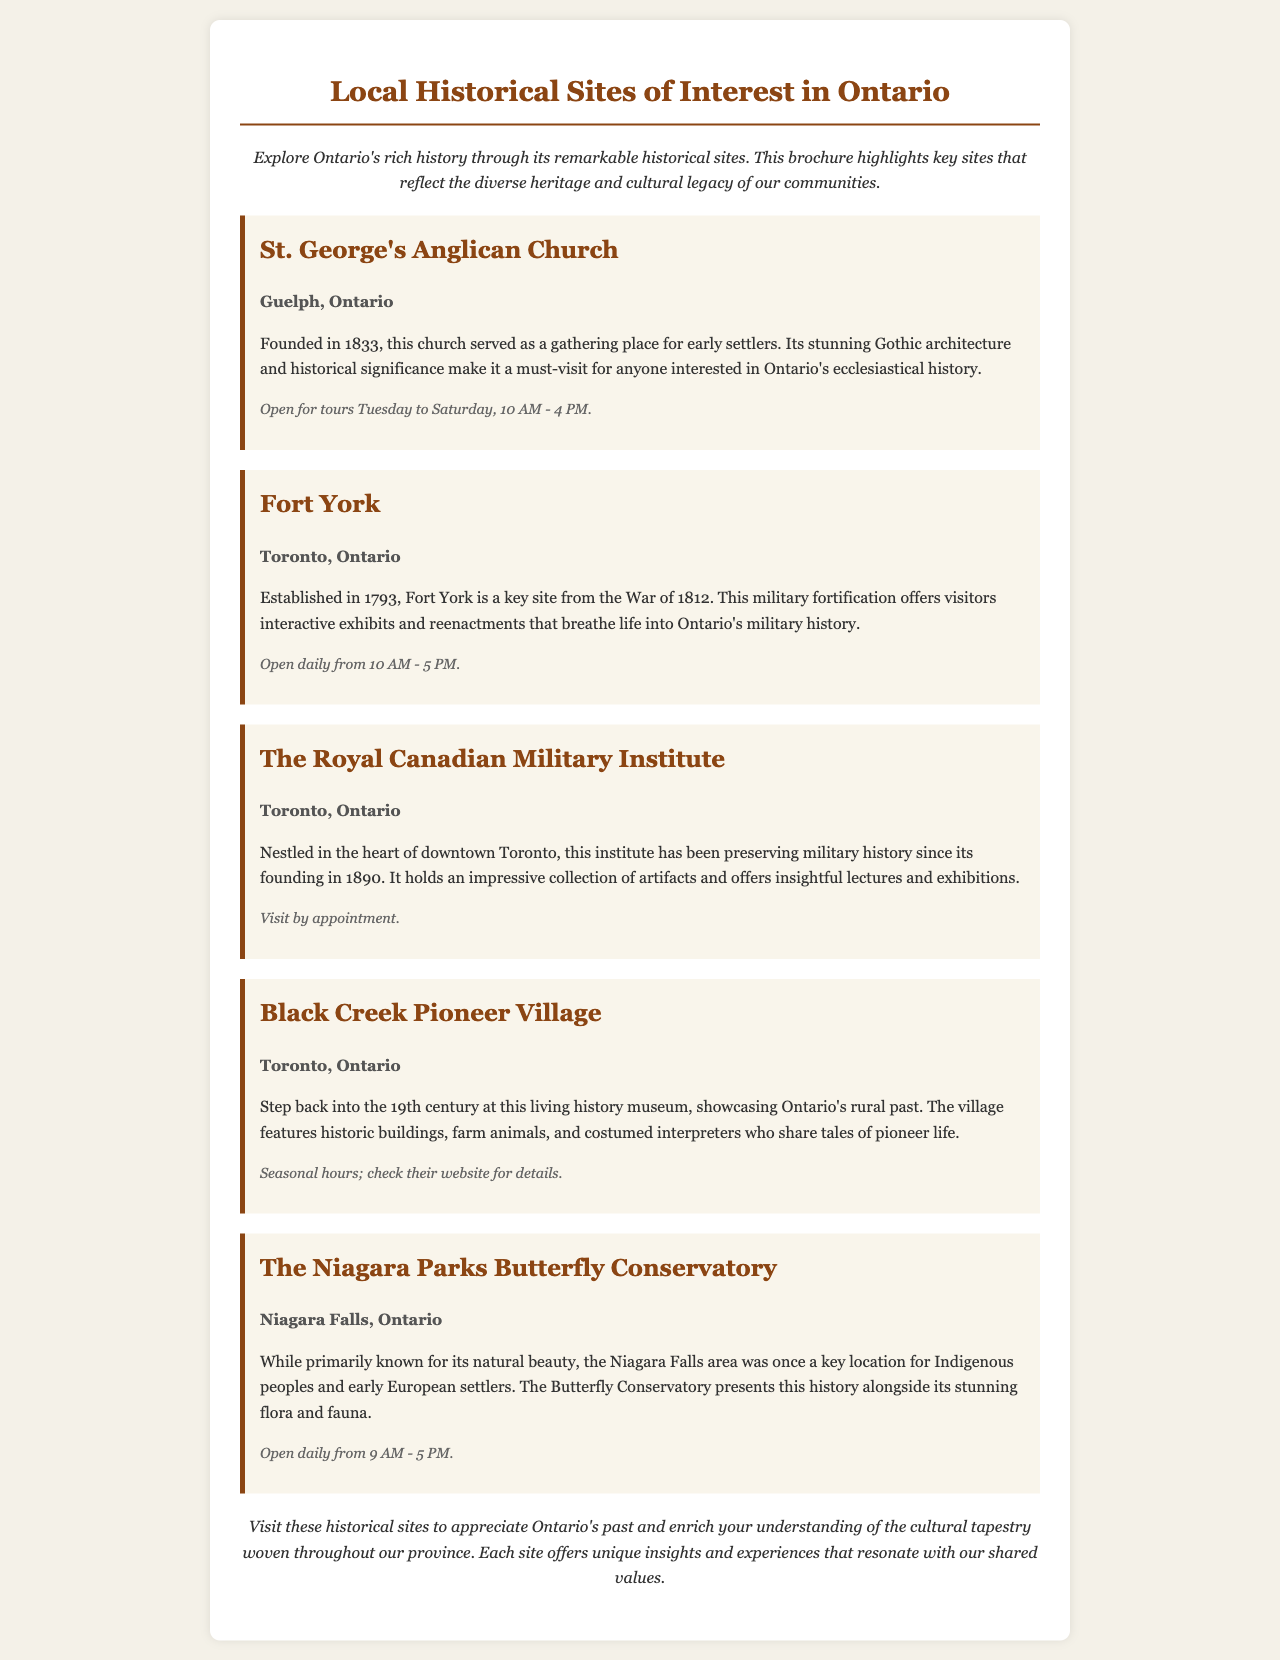What year was St. George's Anglican Church founded? The document states that St. George's Anglican Church was founded in 1833.
Answer: 1833 Where is Fort York located? The document mentions that Fort York is located in Toronto, Ontario.
Answer: Toronto, Ontario What are the open hours for The Royal Canadian Military Institute? The document specifies that visits to The Royal Canadian Military Institute are by appointment.
Answer: By appointment Which historical site features costumed interpreters? The document states that Black Creek Pioneer Village features costumed interpreters who share tales of pioneer life.
Answer: Black Creek Pioneer Village How many historical sites are mentioned in this brochure? The document lists a total of five historical sites of interest in Ontario.
Answer: Five What is the significance of Niagara Falls area mentioned in the document? The document indicates that the Niagara Falls area was a key location for Indigenous peoples and early European settlers.
Answer: Indigenous peoples and early European settlers On which days is St. George's Anglican Church open for tours? According to the document, St. George's Anglican Church is open for tours Tuesday to Saturday.
Answer: Tuesday to Saturday What type of museum is Black Creek Pioneer Village? The document describes Black Creek Pioneer Village as a living history museum.
Answer: Living history museum What overarching theme does the conclusion of the brochure emphasize? The conclusion emphasizes enriching understanding and appreciating Ontario's past and cultural tapestry.
Answer: Appreciation of Ontario's past and cultural tapestry 